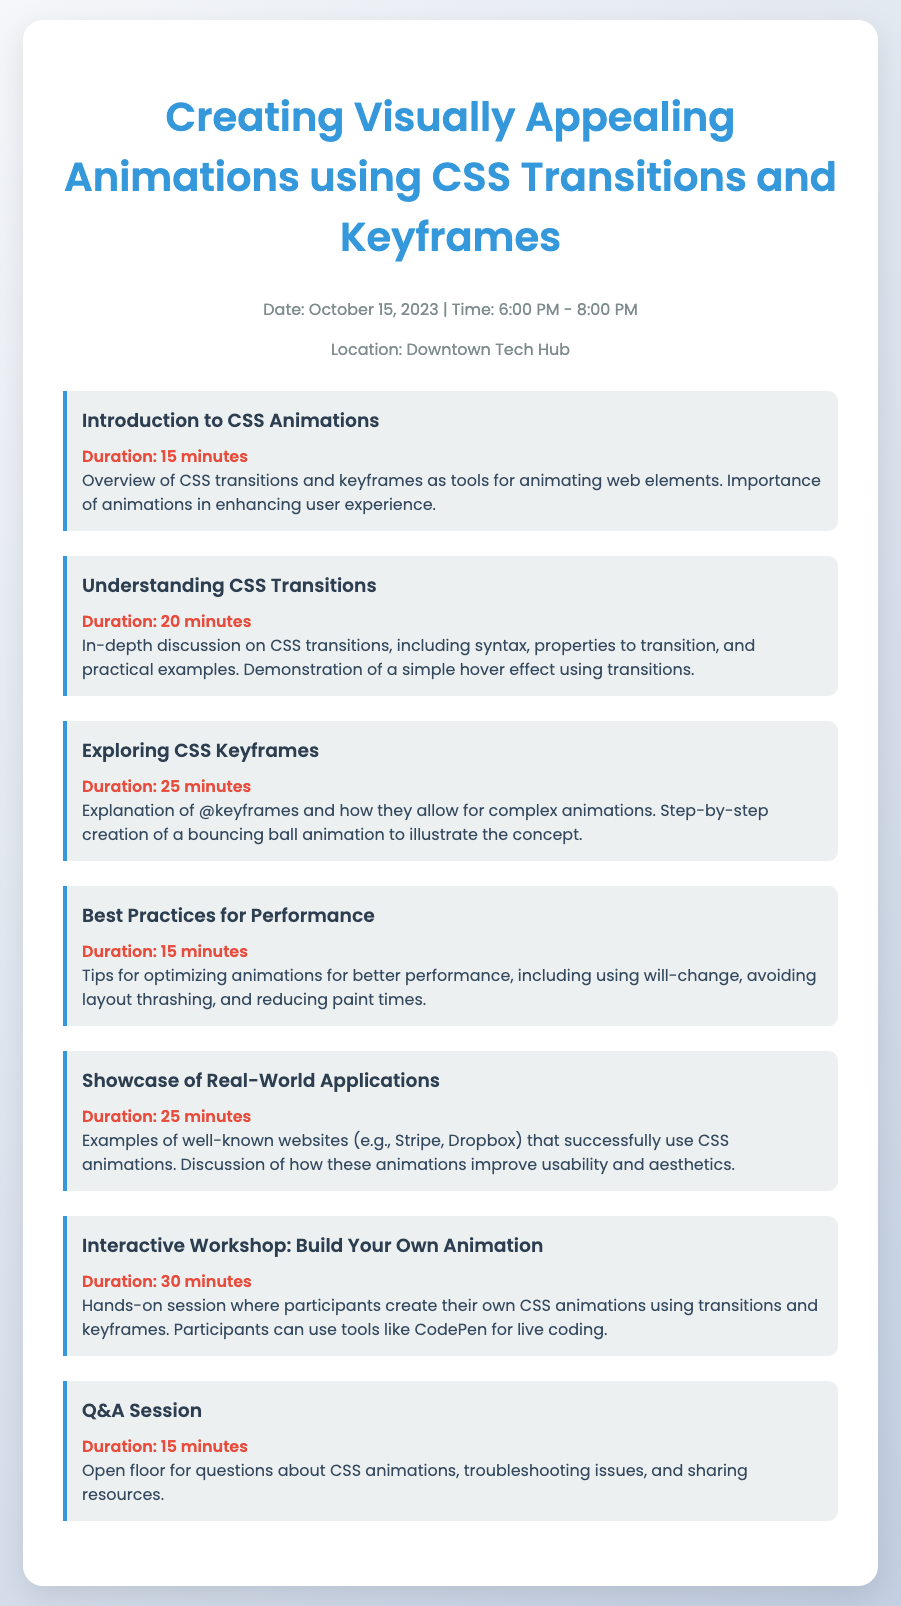What is the date of the meetup? The date is specifically stated in the document under event details.
Answer: October 15, 2023 What is the duration of the "Introduction to CSS Animations" session? The duration is clearly mentioned in the agenda item for the introduction.
Answer: 15 minutes How long is the "Interactive Workshop: Build Your Own Animation" session? The duration for this session is provided in the agenda item.
Answer: 30 minutes What is the main focus of the "Showcase of Real-World Applications" session? The focus is highlighted in the description under the respective agenda item.
Answer: Examples of well-known websites How many main topics are covered in the agenda? The total number of agenda items can be counted from the document.
Answer: 7 What type of session is scheduled before the Q&A Session? The sequence of sessions can be determined by listing the agenda items.
Answer: Interactive Workshop: Build Your Own Animation What is the location of the meetup? The location is mentioned in the event details section of the document.
Answer: Downtown Tech Hub What color is used for the agenda item headings? The document specifies the color used for headings in agenda items.
Answer: #2c3e50 What animation technique is discussed in the "Exploring CSS Keyframes" session? The specific technique is mentioned in the session description.
Answer: @keyframes 